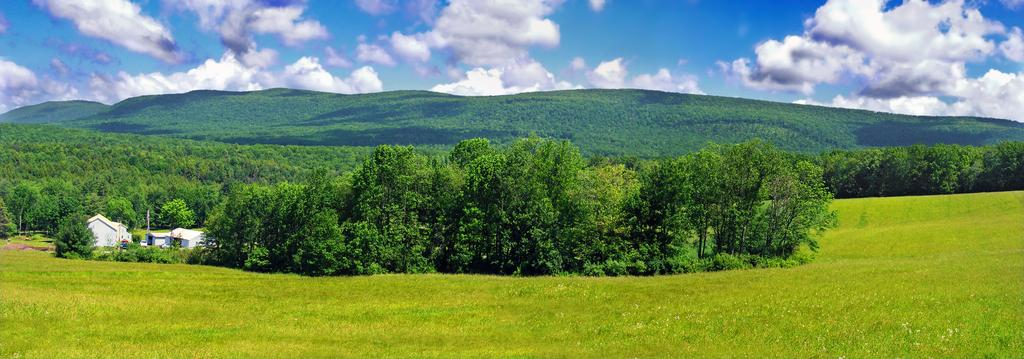What can be seen in the sky in the background of the image? There are clouds in the sky in the background of the image. What type of natural features are visible in the background of the image? There are hills and thicket in the background of the image. What type of vegetation is present in the image? There are trees in the image. What type of structures are present in the image? There are houses in the image. What type of man-made objects are present in the image? There are poles in the image. What type of ground cover is present in the image? There is green grass in the image. How much does the maid weigh in the image? There is no maid present in the image, so it is not possible to determine her weight. What type of man is visible in the image? There is no man present in the image. 